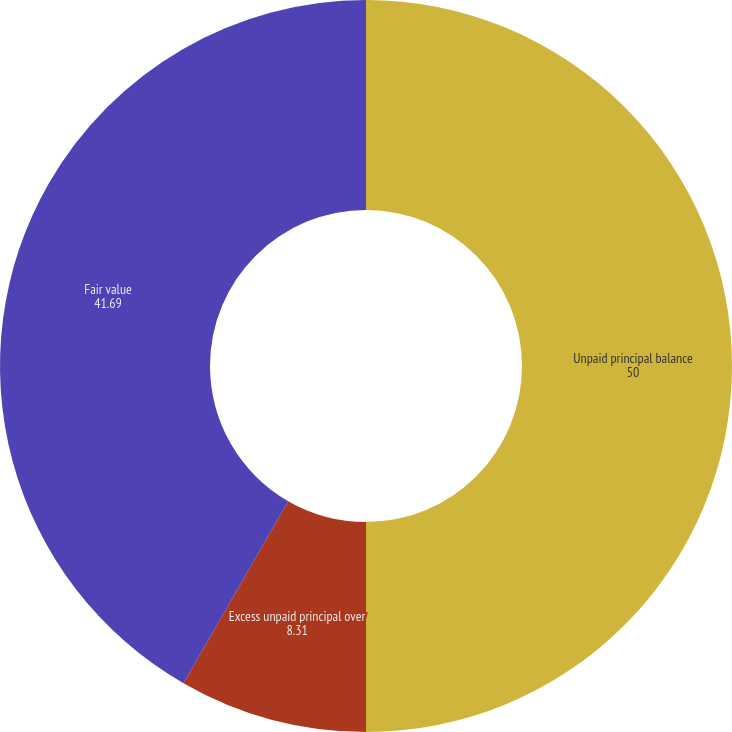Convert chart. <chart><loc_0><loc_0><loc_500><loc_500><pie_chart><fcel>Unpaid principal balance<fcel>Excess unpaid principal over<fcel>Fair value<nl><fcel>50.0%<fcel>8.31%<fcel>41.69%<nl></chart> 